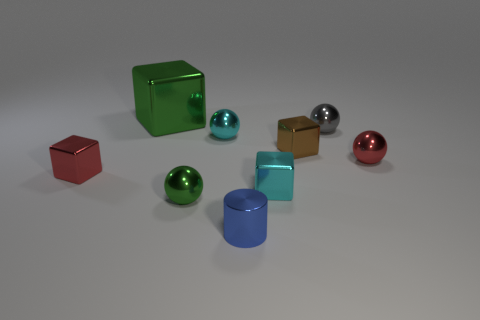Subtract all green shiny spheres. How many spheres are left? 3 Subtract 1 blocks. How many blocks are left? 3 Subtract all gray spheres. How many spheres are left? 3 Add 2 small purple shiny blocks. How many small purple shiny blocks exist? 2 Subtract 0 gray blocks. How many objects are left? 9 Subtract all spheres. How many objects are left? 5 Subtract all cyan cylinders. Subtract all brown cubes. How many cylinders are left? 1 Subtract all cyan cylinders. How many brown cubes are left? 1 Subtract all metallic cylinders. Subtract all cyan things. How many objects are left? 6 Add 2 small blue objects. How many small blue objects are left? 3 